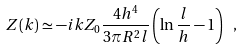<formula> <loc_0><loc_0><loc_500><loc_500>Z ( k ) \simeq - i k Z _ { 0 } \frac { 4 h ^ { 4 } } { 3 \pi R ^ { 2 } l } \left ( \ln \frac { l } { h } - 1 \right ) \ ,</formula> 